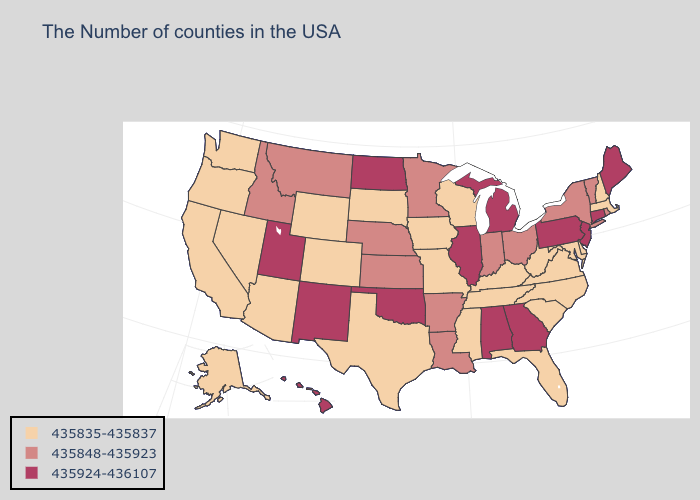What is the value of New York?
Be succinct. 435848-435923. Name the states that have a value in the range 435835-435837?
Answer briefly. Massachusetts, New Hampshire, Delaware, Maryland, Virginia, North Carolina, South Carolina, West Virginia, Florida, Kentucky, Tennessee, Wisconsin, Mississippi, Missouri, Iowa, Texas, South Dakota, Wyoming, Colorado, Arizona, Nevada, California, Washington, Oregon, Alaska. What is the lowest value in the South?
Be succinct. 435835-435837. Which states have the lowest value in the South?
Short answer required. Delaware, Maryland, Virginia, North Carolina, South Carolina, West Virginia, Florida, Kentucky, Tennessee, Mississippi, Texas. Among the states that border Virginia , which have the lowest value?
Give a very brief answer. Maryland, North Carolina, West Virginia, Kentucky, Tennessee. Name the states that have a value in the range 435835-435837?
Give a very brief answer. Massachusetts, New Hampshire, Delaware, Maryland, Virginia, North Carolina, South Carolina, West Virginia, Florida, Kentucky, Tennessee, Wisconsin, Mississippi, Missouri, Iowa, Texas, South Dakota, Wyoming, Colorado, Arizona, Nevada, California, Washington, Oregon, Alaska. Name the states that have a value in the range 435924-436107?
Write a very short answer. Maine, Connecticut, New Jersey, Pennsylvania, Georgia, Michigan, Alabama, Illinois, Oklahoma, North Dakota, New Mexico, Utah, Hawaii. Name the states that have a value in the range 435848-435923?
Short answer required. Rhode Island, Vermont, New York, Ohio, Indiana, Louisiana, Arkansas, Minnesota, Kansas, Nebraska, Montana, Idaho. What is the highest value in the USA?
Write a very short answer. 435924-436107. Name the states that have a value in the range 435848-435923?
Answer briefly. Rhode Island, Vermont, New York, Ohio, Indiana, Louisiana, Arkansas, Minnesota, Kansas, Nebraska, Montana, Idaho. Name the states that have a value in the range 435848-435923?
Quick response, please. Rhode Island, Vermont, New York, Ohio, Indiana, Louisiana, Arkansas, Minnesota, Kansas, Nebraska, Montana, Idaho. Name the states that have a value in the range 435924-436107?
Keep it brief. Maine, Connecticut, New Jersey, Pennsylvania, Georgia, Michigan, Alabama, Illinois, Oklahoma, North Dakota, New Mexico, Utah, Hawaii. What is the highest value in states that border Washington?
Answer briefly. 435848-435923. Name the states that have a value in the range 435924-436107?
Be succinct. Maine, Connecticut, New Jersey, Pennsylvania, Georgia, Michigan, Alabama, Illinois, Oklahoma, North Dakota, New Mexico, Utah, Hawaii. 